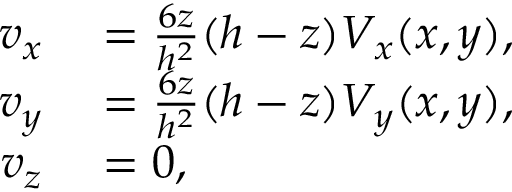Convert formula to latex. <formula><loc_0><loc_0><loc_500><loc_500>\begin{array} { r l } { v _ { x } } & = \frac { 6 z } { h ^ { 2 } } ( h - z ) V _ { x } ( x , y ) , } \\ { v _ { y } } & = \frac { 6 z } { h ^ { 2 } } ( h - z ) V _ { y } ( x , y ) , } \\ { v _ { z } } & = 0 , } \end{array}</formula> 